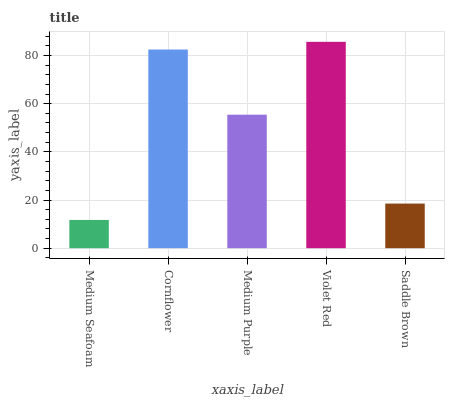Is Medium Seafoam the minimum?
Answer yes or no. Yes. Is Violet Red the maximum?
Answer yes or no. Yes. Is Cornflower the minimum?
Answer yes or no. No. Is Cornflower the maximum?
Answer yes or no. No. Is Cornflower greater than Medium Seafoam?
Answer yes or no. Yes. Is Medium Seafoam less than Cornflower?
Answer yes or no. Yes. Is Medium Seafoam greater than Cornflower?
Answer yes or no. No. Is Cornflower less than Medium Seafoam?
Answer yes or no. No. Is Medium Purple the high median?
Answer yes or no. Yes. Is Medium Purple the low median?
Answer yes or no. Yes. Is Cornflower the high median?
Answer yes or no. No. Is Violet Red the low median?
Answer yes or no. No. 